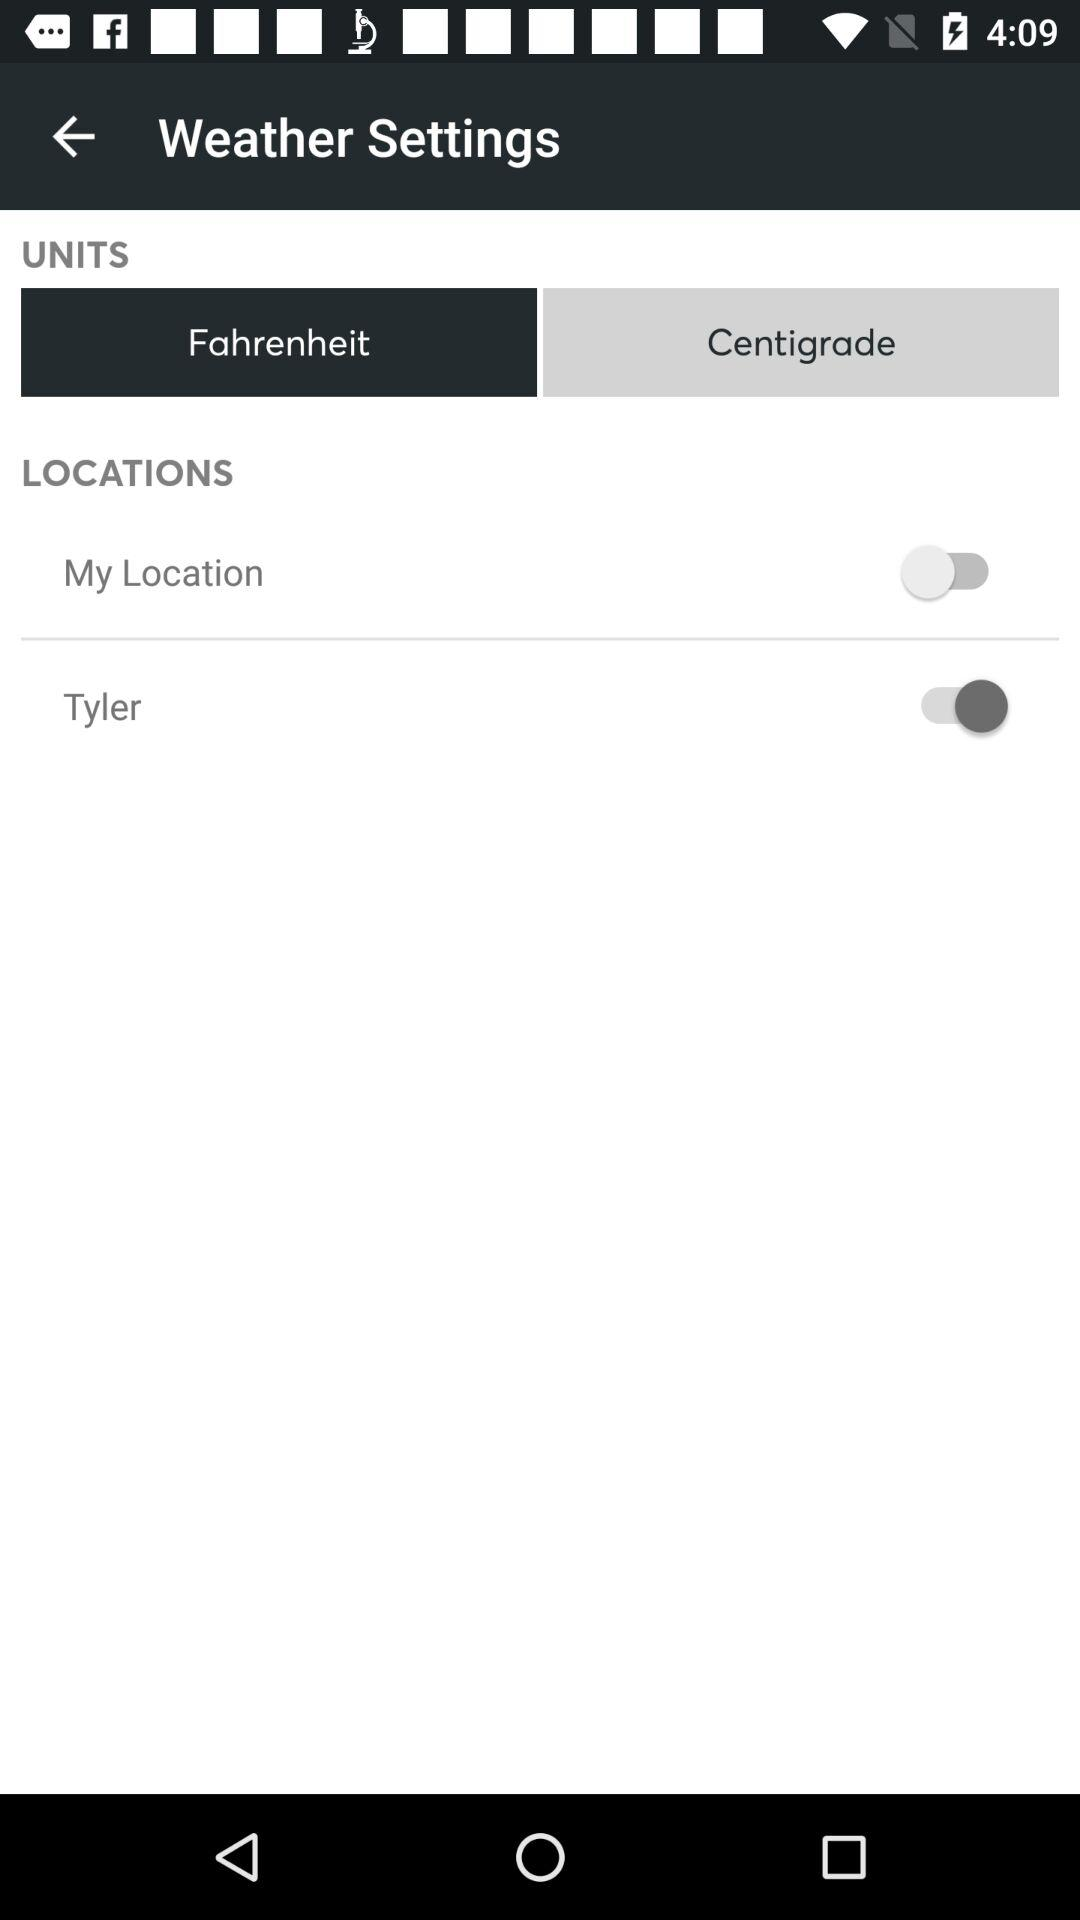What is the status of Tyler? The status is off. 